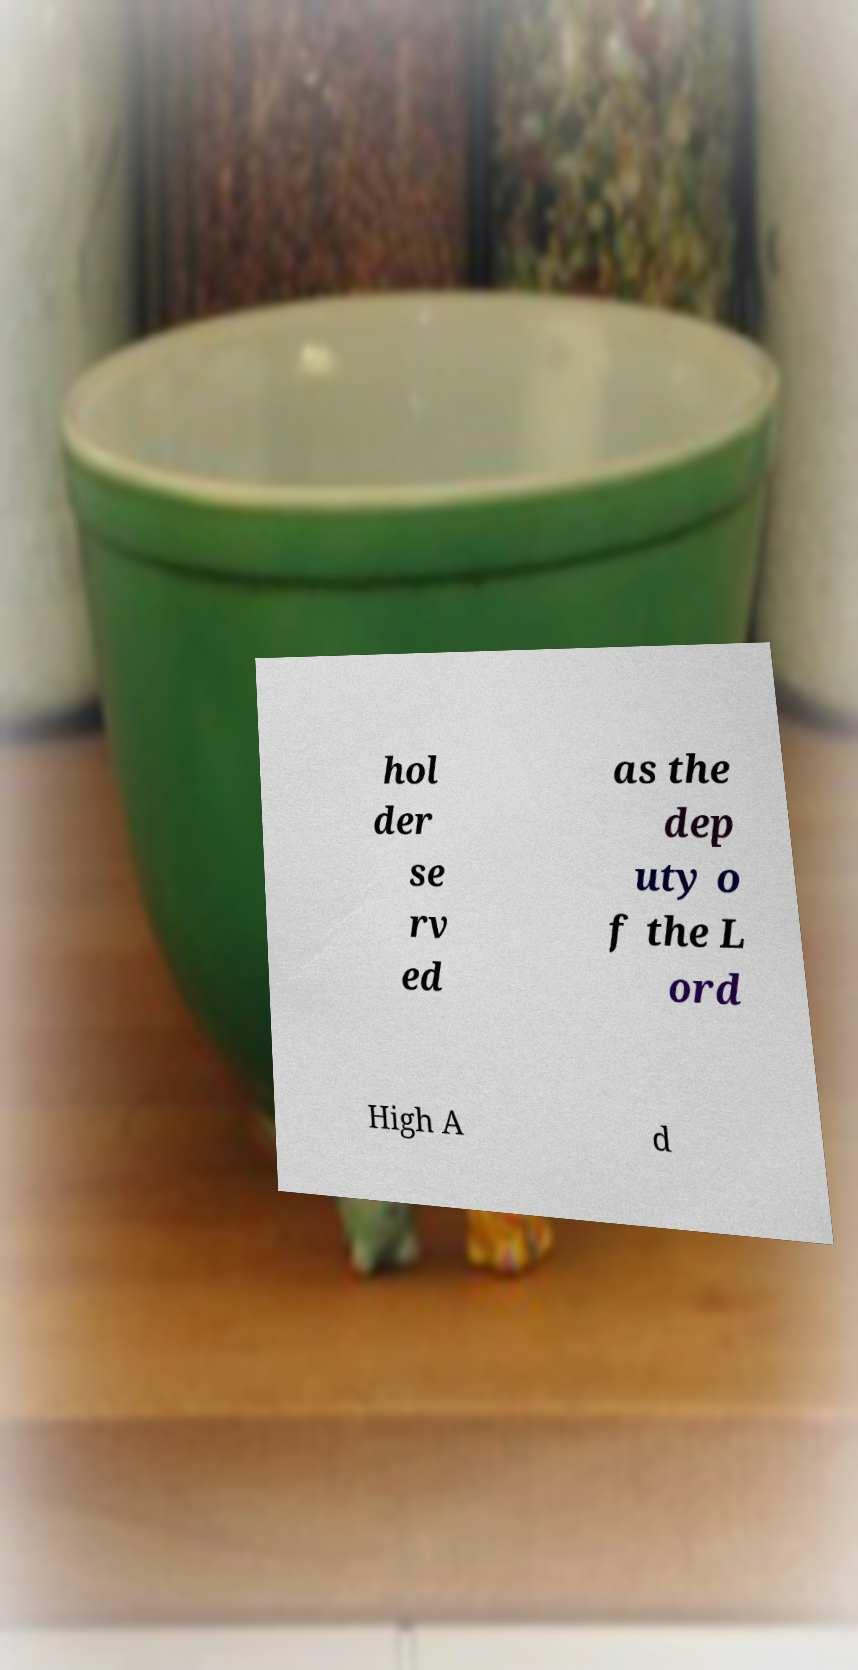Please identify and transcribe the text found in this image. hol der se rv ed as the dep uty o f the L ord High A d 